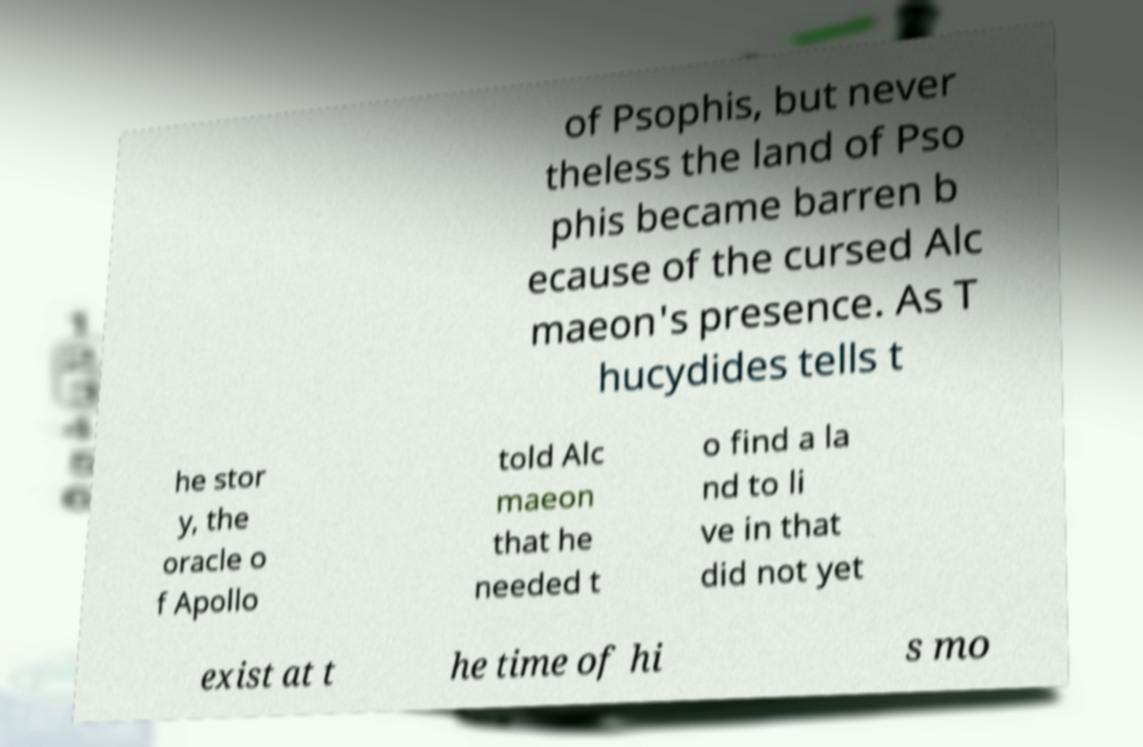Please identify and transcribe the text found in this image. of Psophis, but never theless the land of Pso phis became barren b ecause of the cursed Alc maeon's presence. As T hucydides tells t he stor y, the oracle o f Apollo told Alc maeon that he needed t o find a la nd to li ve in that did not yet exist at t he time of hi s mo 